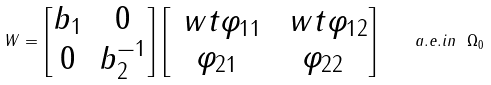Convert formula to latex. <formula><loc_0><loc_0><loc_500><loc_500>W = \begin{bmatrix} b _ { 1 } & 0 \\ 0 & b _ { 2 } ^ { - 1 } \end{bmatrix} \begin{bmatrix} \ w t \varphi _ { 1 1 } & \ w t \varphi _ { 1 2 } \\ \varphi _ { 2 1 } & \varphi _ { 2 2 } \end{bmatrix} \quad a . e . i n \ \Omega _ { 0 }</formula> 